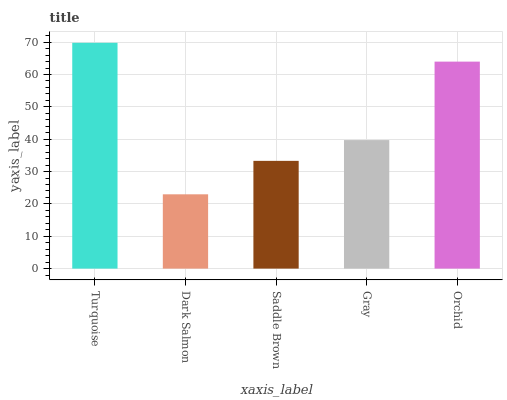Is Dark Salmon the minimum?
Answer yes or no. Yes. Is Turquoise the maximum?
Answer yes or no. Yes. Is Saddle Brown the minimum?
Answer yes or no. No. Is Saddle Brown the maximum?
Answer yes or no. No. Is Saddle Brown greater than Dark Salmon?
Answer yes or no. Yes. Is Dark Salmon less than Saddle Brown?
Answer yes or no. Yes. Is Dark Salmon greater than Saddle Brown?
Answer yes or no. No. Is Saddle Brown less than Dark Salmon?
Answer yes or no. No. Is Gray the high median?
Answer yes or no. Yes. Is Gray the low median?
Answer yes or no. Yes. Is Turquoise the high median?
Answer yes or no. No. Is Orchid the low median?
Answer yes or no. No. 